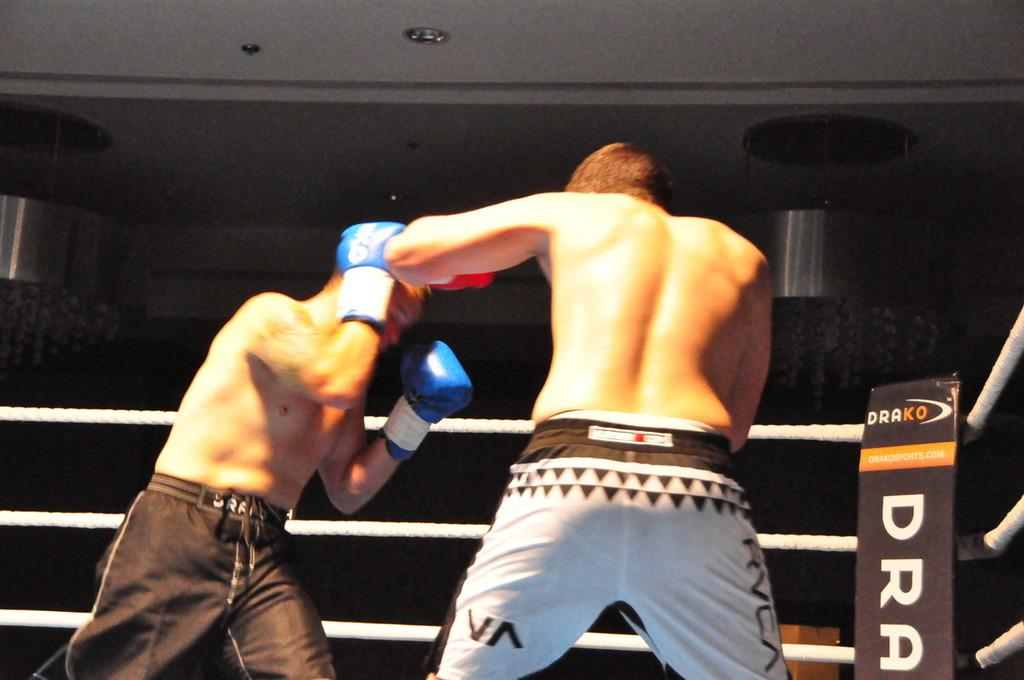What are the two persons in the image doing? The two persons are boxing in the center of the image. What can be seen in the background of the image? There is railing and a wall in the background of the image. What is visible at the top of the image? There is a ceiling visible at the top of the image. What might be used for illumination in the image? There are lights present in the image. What type of soup is being served to the boxers in the image? There is no soup present in the image; it features two persons boxing. What is the profit margin for the boxing match in the image? There is no information about profit margins in the image, as it focuses on the boxing action. 